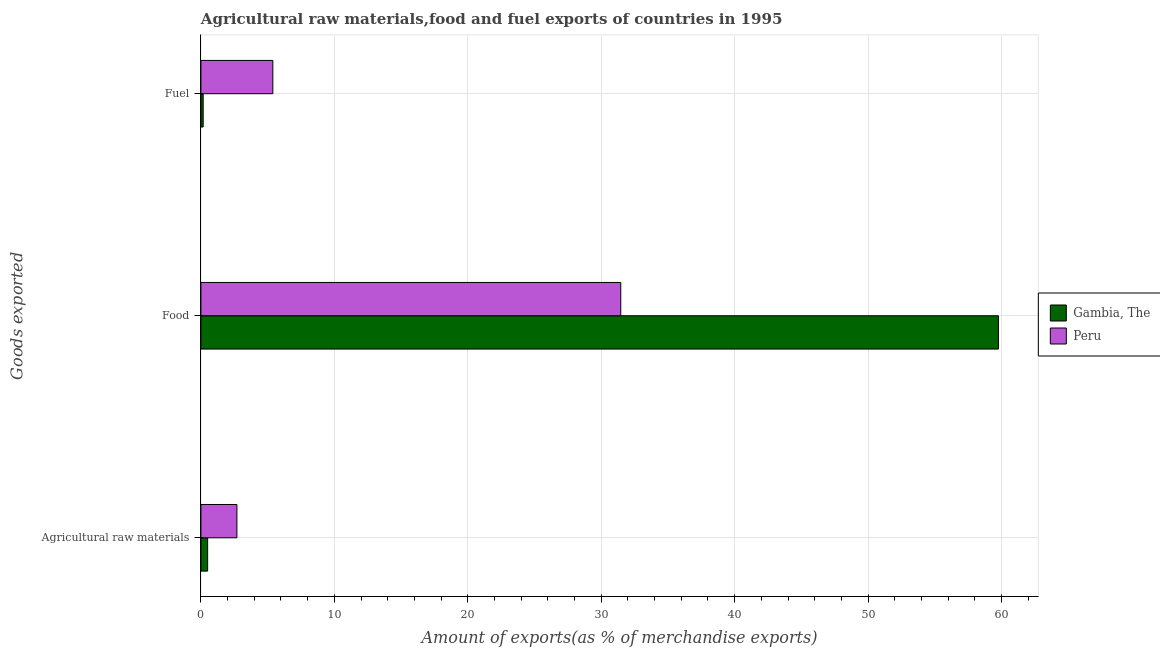How many bars are there on the 3rd tick from the top?
Your answer should be very brief. 2. What is the label of the 1st group of bars from the top?
Provide a short and direct response. Fuel. What is the percentage of food exports in Gambia, The?
Offer a terse response. 59.77. Across all countries, what is the maximum percentage of raw materials exports?
Offer a terse response. 2.7. Across all countries, what is the minimum percentage of fuel exports?
Keep it short and to the point. 0.17. In which country was the percentage of raw materials exports maximum?
Make the answer very short. Peru. In which country was the percentage of raw materials exports minimum?
Give a very brief answer. Gambia, The. What is the total percentage of raw materials exports in the graph?
Your answer should be compact. 3.2. What is the difference between the percentage of fuel exports in Peru and that in Gambia, The?
Provide a short and direct response. 5.22. What is the difference between the percentage of raw materials exports in Gambia, The and the percentage of fuel exports in Peru?
Keep it short and to the point. -4.89. What is the average percentage of fuel exports per country?
Keep it short and to the point. 2.78. What is the difference between the percentage of food exports and percentage of raw materials exports in Peru?
Make the answer very short. 28.77. What is the ratio of the percentage of raw materials exports in Gambia, The to that in Peru?
Give a very brief answer. 0.19. What is the difference between the highest and the second highest percentage of raw materials exports?
Your response must be concise. 2.19. What is the difference between the highest and the lowest percentage of fuel exports?
Your response must be concise. 5.22. What does the 2nd bar from the top in Fuel represents?
Your answer should be compact. Gambia, The. What does the 2nd bar from the bottom in Food represents?
Keep it short and to the point. Peru. How many bars are there?
Ensure brevity in your answer.  6. Are the values on the major ticks of X-axis written in scientific E-notation?
Your response must be concise. No. Does the graph contain any zero values?
Provide a short and direct response. No. Does the graph contain grids?
Your answer should be compact. Yes. What is the title of the graph?
Offer a very short reply. Agricultural raw materials,food and fuel exports of countries in 1995. What is the label or title of the X-axis?
Make the answer very short. Amount of exports(as % of merchandise exports). What is the label or title of the Y-axis?
Offer a very short reply. Goods exported. What is the Amount of exports(as % of merchandise exports) of Gambia, The in Agricultural raw materials?
Give a very brief answer. 0.5. What is the Amount of exports(as % of merchandise exports) of Peru in Agricultural raw materials?
Make the answer very short. 2.7. What is the Amount of exports(as % of merchandise exports) of Gambia, The in Food?
Keep it short and to the point. 59.77. What is the Amount of exports(as % of merchandise exports) of Peru in Food?
Provide a short and direct response. 31.46. What is the Amount of exports(as % of merchandise exports) of Gambia, The in Fuel?
Ensure brevity in your answer.  0.17. What is the Amount of exports(as % of merchandise exports) of Peru in Fuel?
Offer a very short reply. 5.39. Across all Goods exported, what is the maximum Amount of exports(as % of merchandise exports) of Gambia, The?
Your answer should be compact. 59.77. Across all Goods exported, what is the maximum Amount of exports(as % of merchandise exports) in Peru?
Your answer should be very brief. 31.46. Across all Goods exported, what is the minimum Amount of exports(as % of merchandise exports) in Gambia, The?
Make the answer very short. 0.17. Across all Goods exported, what is the minimum Amount of exports(as % of merchandise exports) of Peru?
Provide a short and direct response. 2.7. What is the total Amount of exports(as % of merchandise exports) of Gambia, The in the graph?
Your answer should be very brief. 60.44. What is the total Amount of exports(as % of merchandise exports) of Peru in the graph?
Your answer should be very brief. 39.55. What is the difference between the Amount of exports(as % of merchandise exports) in Gambia, The in Agricultural raw materials and that in Food?
Provide a short and direct response. -59.26. What is the difference between the Amount of exports(as % of merchandise exports) of Peru in Agricultural raw materials and that in Food?
Give a very brief answer. -28.77. What is the difference between the Amount of exports(as % of merchandise exports) in Gambia, The in Agricultural raw materials and that in Fuel?
Give a very brief answer. 0.34. What is the difference between the Amount of exports(as % of merchandise exports) in Peru in Agricultural raw materials and that in Fuel?
Make the answer very short. -2.69. What is the difference between the Amount of exports(as % of merchandise exports) in Gambia, The in Food and that in Fuel?
Your answer should be compact. 59.6. What is the difference between the Amount of exports(as % of merchandise exports) in Peru in Food and that in Fuel?
Provide a succinct answer. 26.07. What is the difference between the Amount of exports(as % of merchandise exports) of Gambia, The in Agricultural raw materials and the Amount of exports(as % of merchandise exports) of Peru in Food?
Your answer should be compact. -30.96. What is the difference between the Amount of exports(as % of merchandise exports) of Gambia, The in Agricultural raw materials and the Amount of exports(as % of merchandise exports) of Peru in Fuel?
Offer a very short reply. -4.89. What is the difference between the Amount of exports(as % of merchandise exports) of Gambia, The in Food and the Amount of exports(as % of merchandise exports) of Peru in Fuel?
Provide a succinct answer. 54.38. What is the average Amount of exports(as % of merchandise exports) in Gambia, The per Goods exported?
Offer a terse response. 20.15. What is the average Amount of exports(as % of merchandise exports) in Peru per Goods exported?
Your answer should be compact. 13.18. What is the difference between the Amount of exports(as % of merchandise exports) of Gambia, The and Amount of exports(as % of merchandise exports) of Peru in Agricultural raw materials?
Provide a succinct answer. -2.19. What is the difference between the Amount of exports(as % of merchandise exports) of Gambia, The and Amount of exports(as % of merchandise exports) of Peru in Food?
Offer a very short reply. 28.3. What is the difference between the Amount of exports(as % of merchandise exports) of Gambia, The and Amount of exports(as % of merchandise exports) of Peru in Fuel?
Keep it short and to the point. -5.22. What is the ratio of the Amount of exports(as % of merchandise exports) in Gambia, The in Agricultural raw materials to that in Food?
Make the answer very short. 0.01. What is the ratio of the Amount of exports(as % of merchandise exports) of Peru in Agricultural raw materials to that in Food?
Offer a very short reply. 0.09. What is the ratio of the Amount of exports(as % of merchandise exports) of Gambia, The in Agricultural raw materials to that in Fuel?
Provide a succinct answer. 2.98. What is the ratio of the Amount of exports(as % of merchandise exports) of Peru in Agricultural raw materials to that in Fuel?
Offer a terse response. 0.5. What is the ratio of the Amount of exports(as % of merchandise exports) of Gambia, The in Food to that in Fuel?
Offer a very short reply. 352.91. What is the ratio of the Amount of exports(as % of merchandise exports) in Peru in Food to that in Fuel?
Provide a short and direct response. 5.84. What is the difference between the highest and the second highest Amount of exports(as % of merchandise exports) in Gambia, The?
Provide a succinct answer. 59.26. What is the difference between the highest and the second highest Amount of exports(as % of merchandise exports) in Peru?
Your answer should be very brief. 26.07. What is the difference between the highest and the lowest Amount of exports(as % of merchandise exports) in Gambia, The?
Offer a terse response. 59.6. What is the difference between the highest and the lowest Amount of exports(as % of merchandise exports) in Peru?
Ensure brevity in your answer.  28.77. 